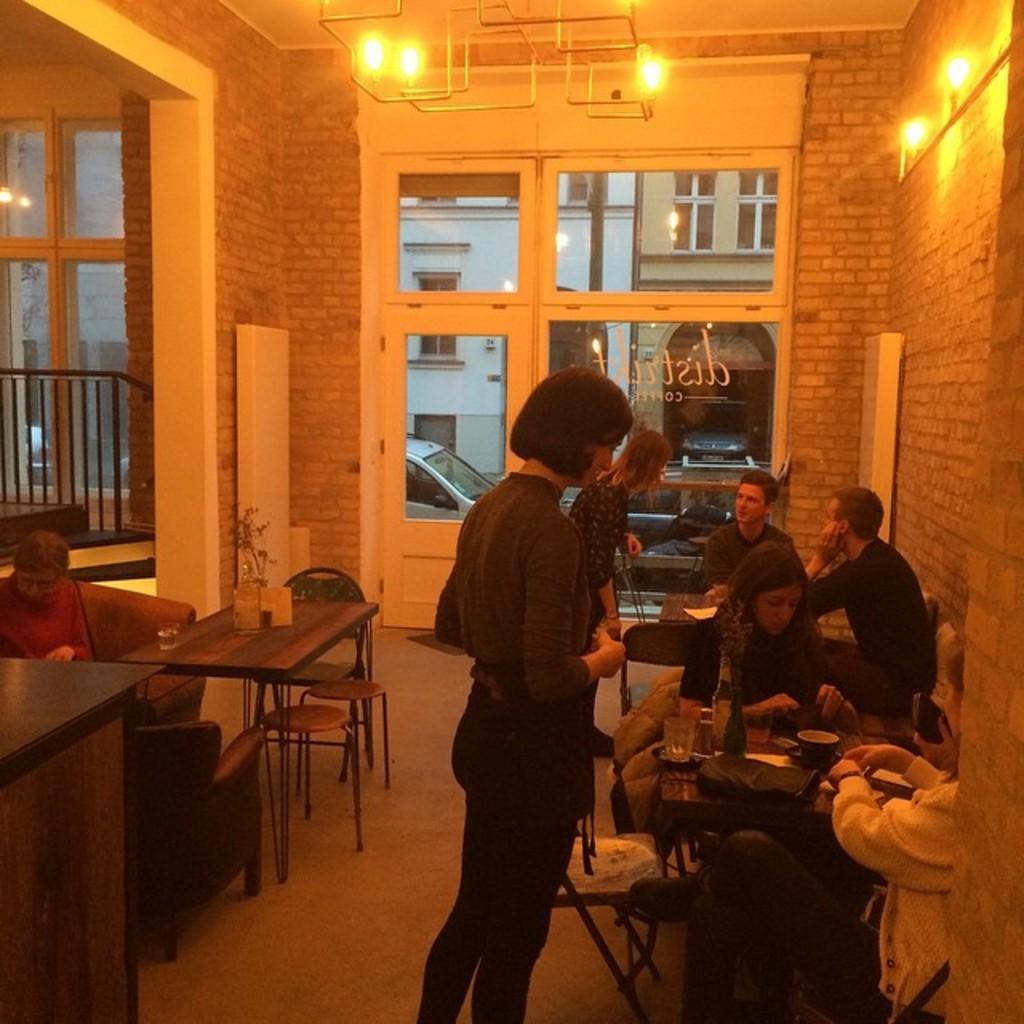Could you give a brief overview of what you see in this image? In this image I can see a building which consists of lights, a glass door. Here it's a woman standing over here. This is the table and people are having their meal. This women is in a t shirt and a pant, she has short hair. 